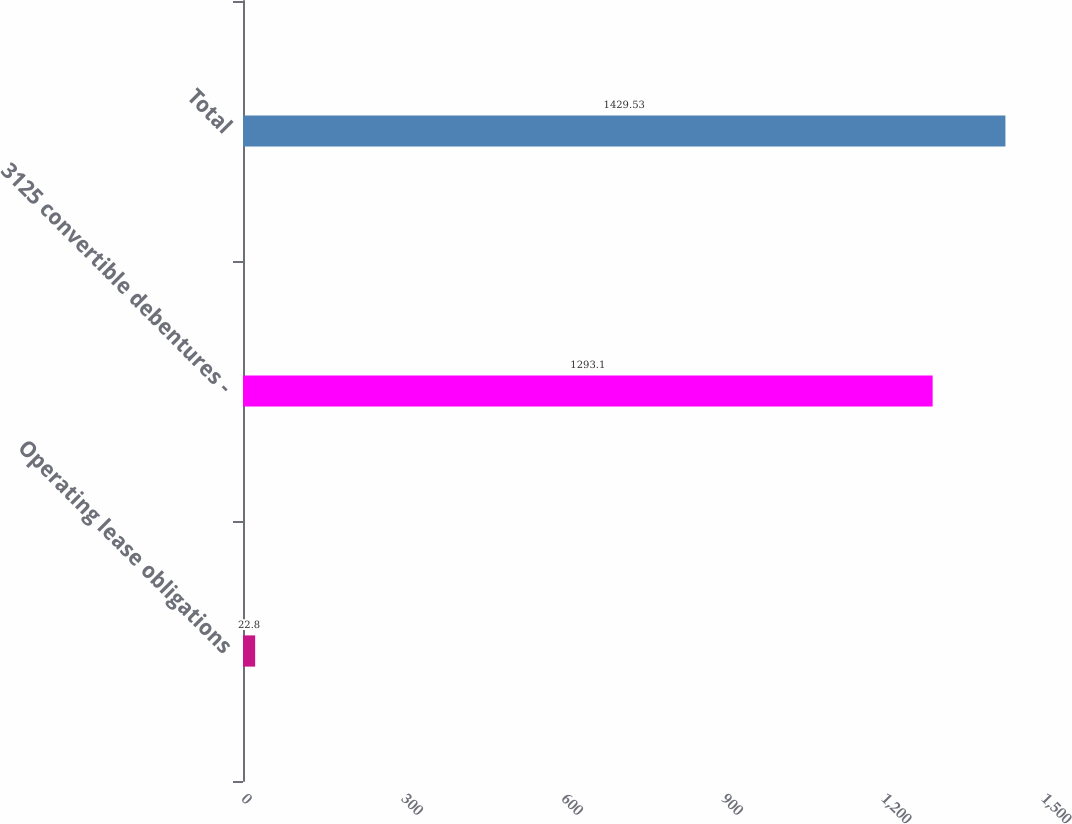<chart> <loc_0><loc_0><loc_500><loc_500><bar_chart><fcel>Operating lease obligations<fcel>3125 convertible debentures -<fcel>Total<nl><fcel>22.8<fcel>1293.1<fcel>1429.53<nl></chart> 